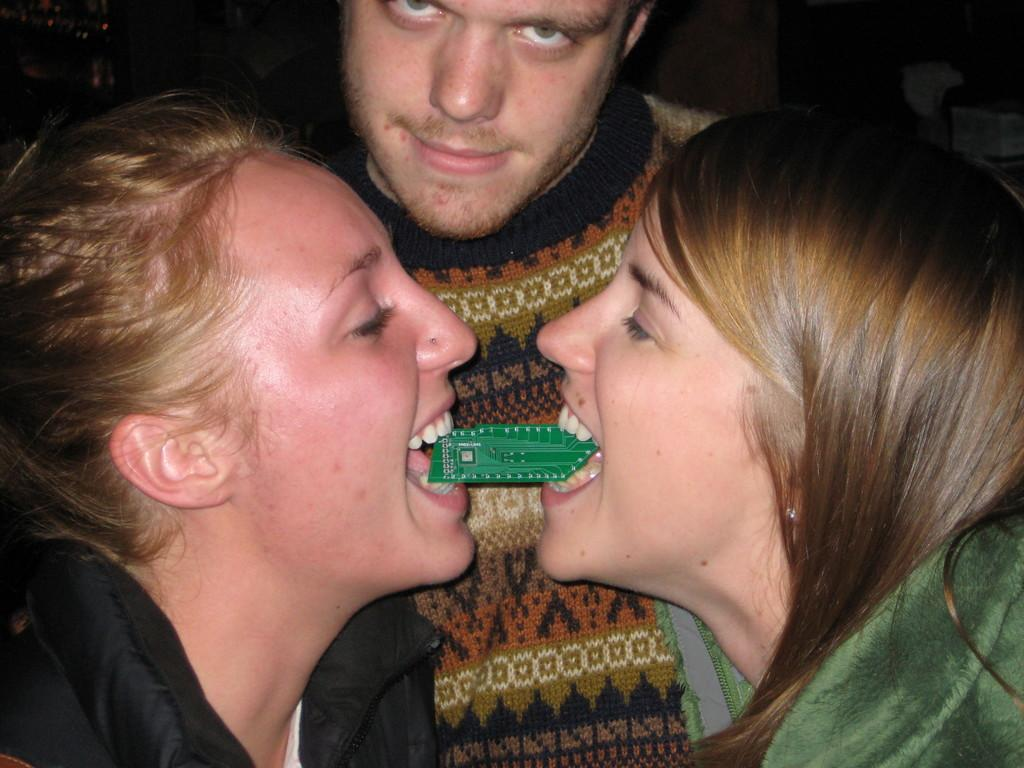How many people are in the image? There is a man and two women in the image. What are the women doing in the image? The women are holding an object with their mouths in the image. What can be observed about the background of the image? The background of the image is dark. What type of profit can be seen in the image? There is no mention of profit in the image, as it features a man and two women holding an object with their mouths against a dark background. 